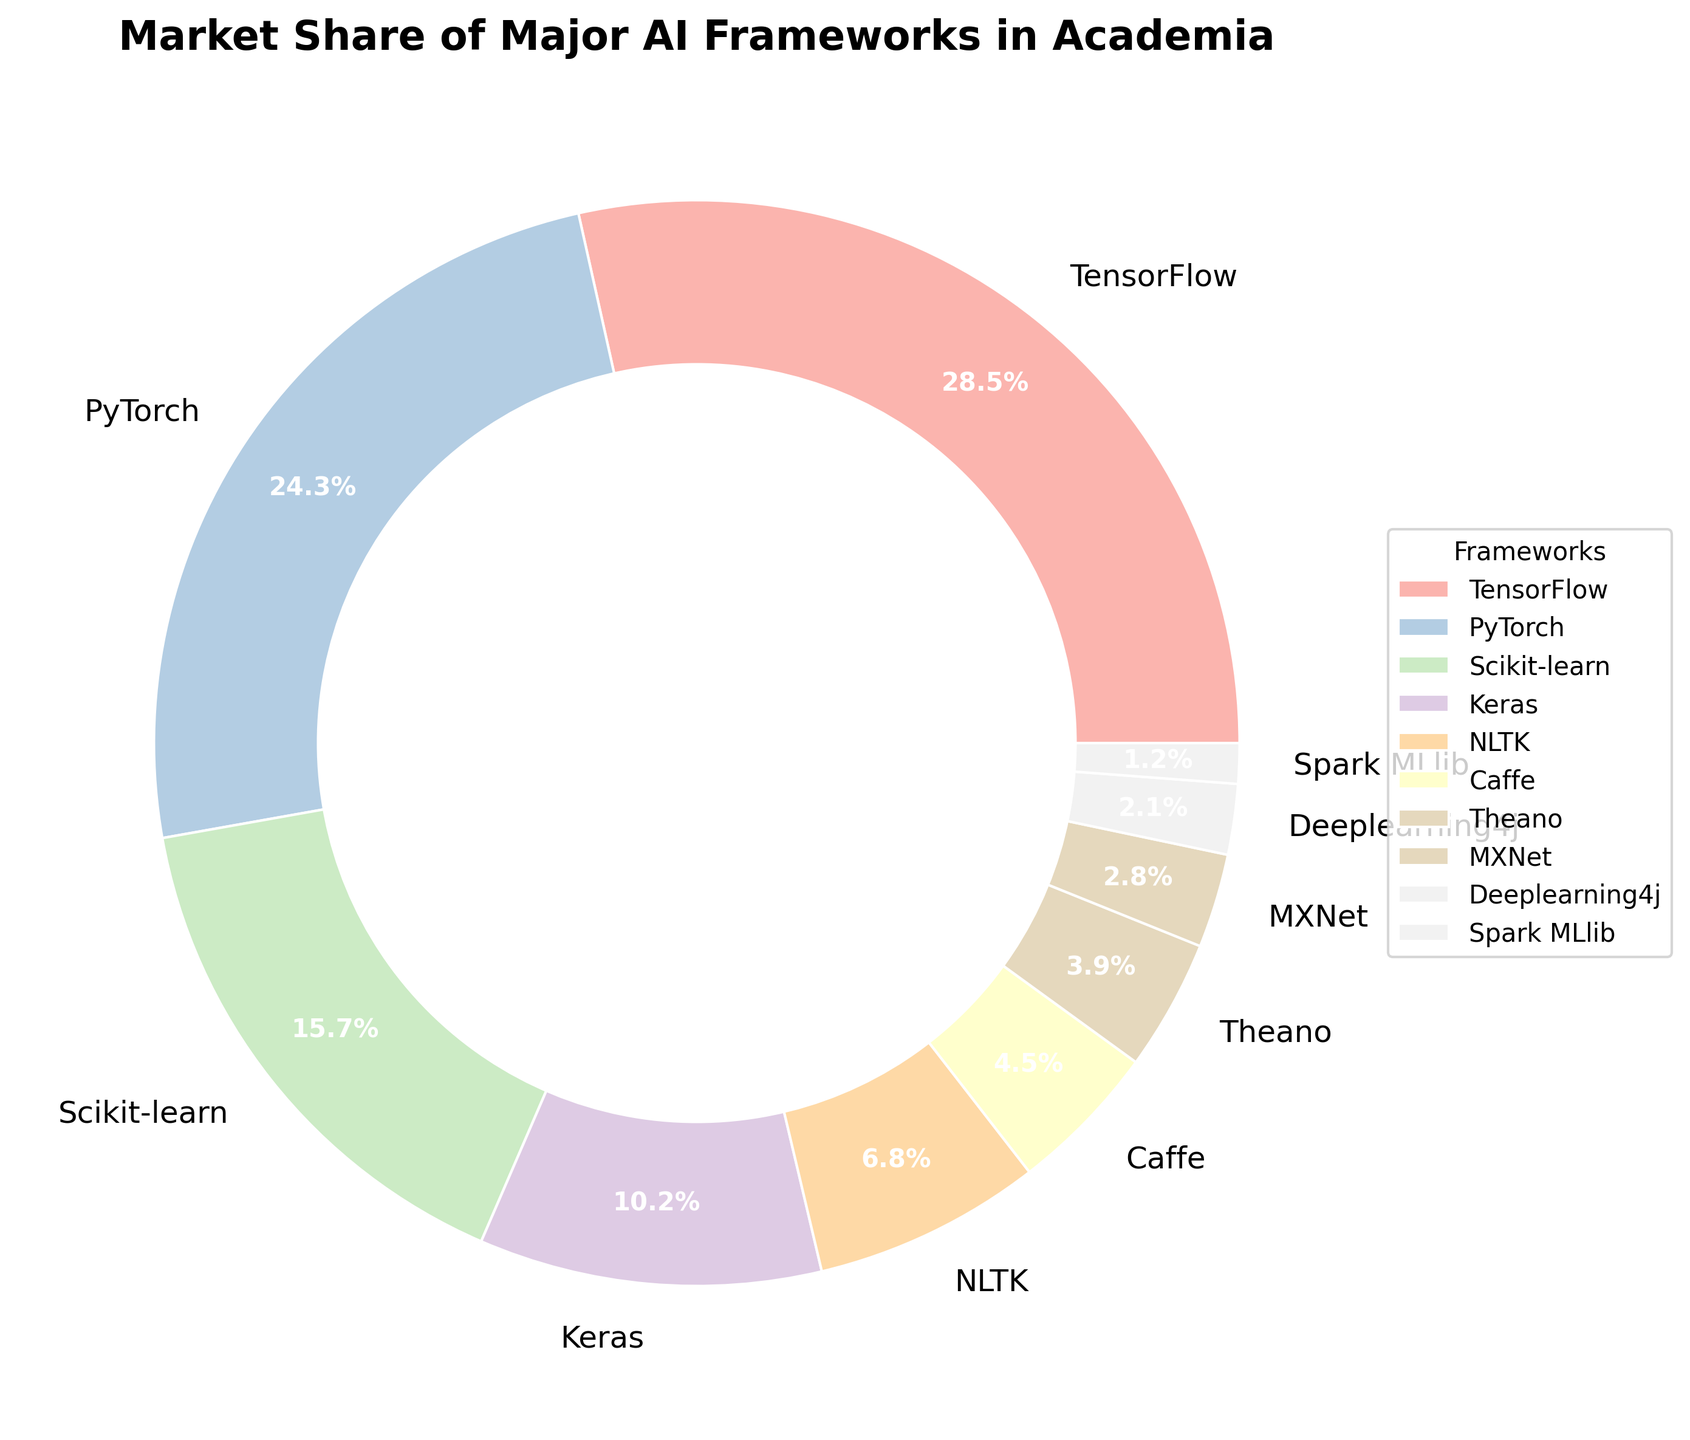What is the market share of TensorFlow? The market share of TensorFlow is displayed on the pie chart as a segment labeled with its percentage.
Answer: 28.5% Which AI framework has a slightly higher market share than Scikit-learn? By comparing the segments near Scikit-learn's 15.7%, PyTorch has a slightly higher market share at 24.3%.
Answer: PyTorch How much larger is TensorFlow's market share compared to Theano's, both in percentage points and visually? TensorFlow's market share is 28.5% and Theano's is 3.9%. The difference is 28.5 - 3.9 = 24.6 percentage points. The visual difference is significant as TensorFlow occupies a much larger segment in the pie chart.
Answer: 24.6 percentage points What's the combined market share of Keras and NLTK? Keras has 10.2% and NLTK has 6.8%. Summing these percentages gives 10.2 + 6.8 = 17.0%.
Answer: 17.0% Which framework has the smallest market share and what is it? The smallest segment on the pie chart corresponds to Spark MLlib, which has a market share of 1.2%.
Answer: Spark MLlib, 1.2% Are there any frameworks whose combined market share is equal to or greater than that of TensorFlow? If so, which ones? We need to find if there are other frameworks whose combined market share equals or exceeds 28.5%. Adding PyTorch (24.3%) and any framework (e.g., Scikit-learn 15.7%) exceeds 28.5%.
Answer: PyTorch and Scikit-learn What's the average market share of all the listed frameworks? Sum of percentages: 28.5 + 24.3 + 15.7 + 10.2 + 6.8 + 4.5 + 3.9 + 2.8 + 2.1 + 1.2 = 100%. Dividing by the 10 frameworks: 100 / 10 = 10.0%.
Answer: 10.0% What's the difference in market share between the third most popular and the least popular frameworks? The third most popular framework is Scikit-learn with 15.7%, and the least popular is Spark MLlib with 1.2%. The difference is 15.7 - 1.2 = 14.5%.
Answer: 14.5% If you were to divide the frameworks into two groups, those above and below a market share of 5%, how many frameworks would fall in each group? Frameworks above 5%: TensorFlow, PyTorch, Scikit-learn, Keras, NLTK (total 5). Frameworks below 5%: Caffe, Theano, MXNet, Deeplearning4j, Spark MLlib (total 5).
Answer: 5 in each group Which framework uses the pastel green color, and what is its market share? Visual inspection shows that the segment with pastel green corresponds to PyTorch. Its market share is 24.3%.
Answer: PyTorch, 24.3% 